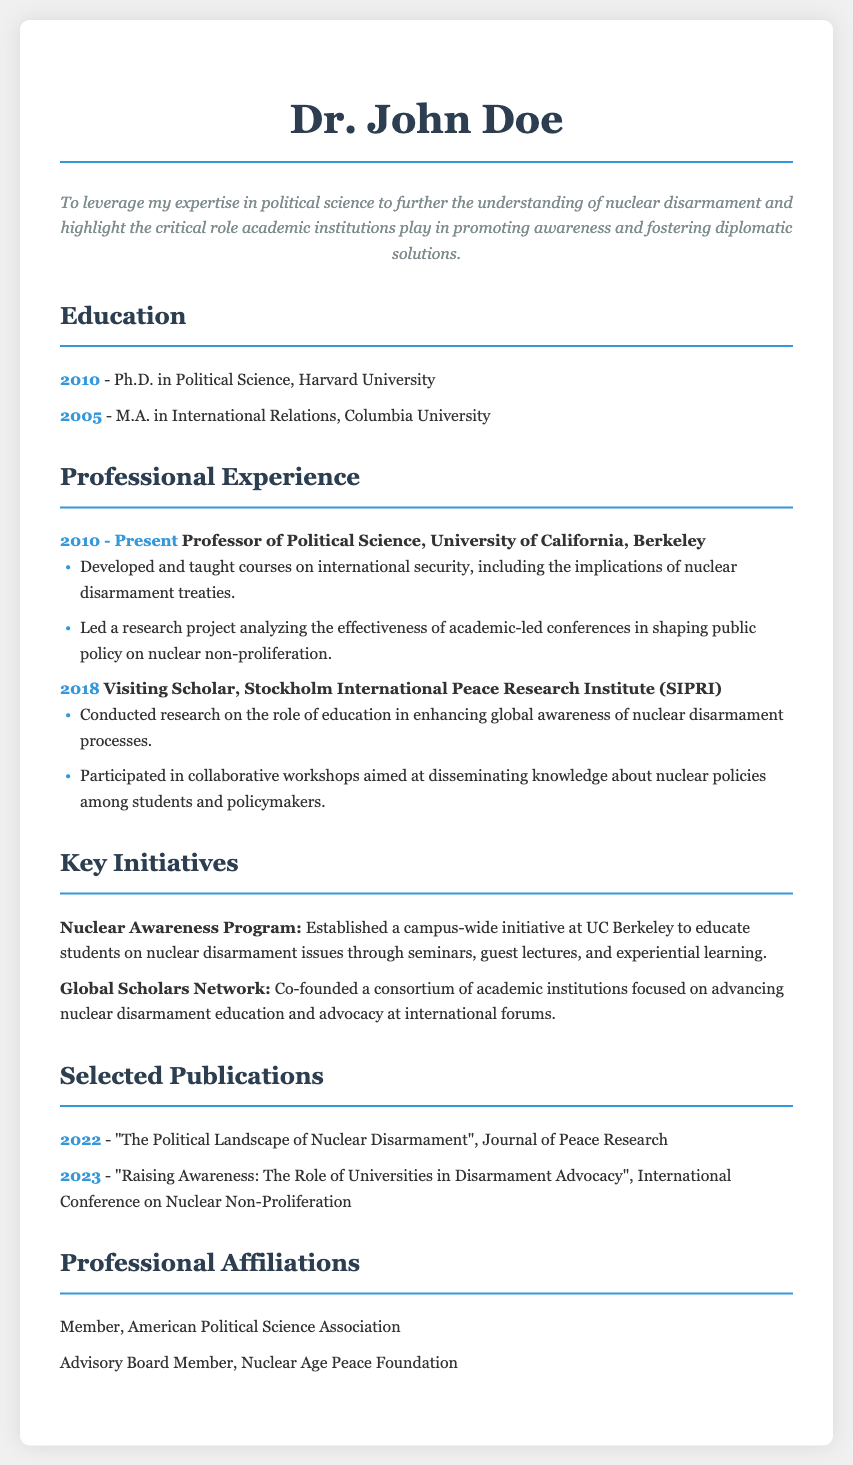What is the title of the resume? The title is prominently displayed at the top of the document.
Answer: Resume - Political Science Professor What year did Dr. John Doe receive his Ph.D.? The year is listed in the education section of the document.
Answer: 2010 Which institution is Dr. John Doe currently affiliated with? This information is provided in the professional experience section of the resume.
Answer: University of California, Berkeley What is one key initiative mentioned in the resume? The initiatives section describes several key initiatives undertaken by Dr. John Doe.
Answer: Nuclear Awareness Program In what year was the publication "Raising Awareness: The Role of Universities in Disarmament Advocacy" released? This information is located in the selected publications section.
Answer: 2023 What type of program did Dr. John Doe establish at UC Berkeley? The description of the initiative clarifies this point in the document.
Answer: Campus-wide initiative Which two affiliations are listed for Dr. John Doe? The professional affiliations section contains this information.
Answer: American Political Science Association, Nuclear Age Peace Foundation What role did Dr. John Doe serve in 2018? The professional experience section provides details on his position that year.
Answer: Visiting Scholar 